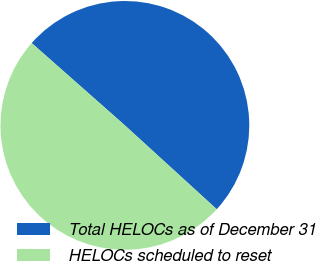<chart> <loc_0><loc_0><loc_500><loc_500><pie_chart><fcel>Total HELOCs as of December 31<fcel>HELOCs scheduled to reset<nl><fcel>50.26%<fcel>49.74%<nl></chart> 